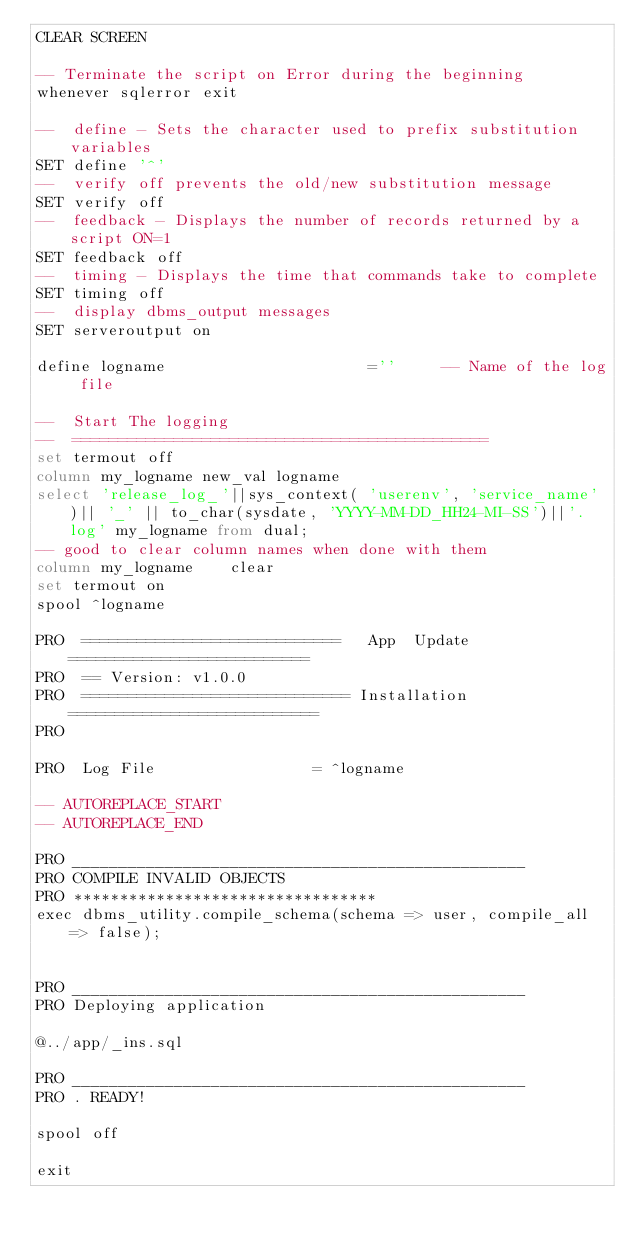Convert code to text. <code><loc_0><loc_0><loc_500><loc_500><_SQL_>CLEAR SCREEN

-- Terminate the script on Error during the beginning
whenever sqlerror exit

--  define - Sets the character used to prefix substitution variables
SET define '^'
--  verify off prevents the old/new substitution message
SET verify off
--  feedback - Displays the number of records returned by a script ON=1
SET feedback off
--  timing - Displays the time that commands take to complete
SET timing off
--  display dbms_output messages
SET serveroutput on

define logname                      =''     -- Name of the log file

--  Start The logging
--  =============================================
set termout off
column my_logname new_val logname
select 'release_log_'||sys_context( 'userenv', 'service_name' )|| '_' || to_char(sysdate, 'YYYY-MM-DD_HH24-MI-SS')||'.log' my_logname from dual;
-- good to clear column names when done with them
column my_logname    clear
set termout on
spool ^logname

PRO  ============================   App  Update  ==========================
PRO  == Version: v1.0.0
PRO  ============================= Installation ===========================
PRO

PRO  Log File                 = ^logname

-- AUTOREPLACE_START
-- AUTOREPLACE_END

PRO _________________________________________________
PRO COMPILE INVALID OBJECTS
PRO *********************************
exec dbms_utility.compile_schema(schema => user, compile_all => false);


PRO _________________________________________________
PRO Deploying application

@../app/_ins.sql

PRO _________________________________________________
PRO . READY!

spool off

exit
</code> 